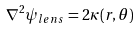Convert formula to latex. <formula><loc_0><loc_0><loc_500><loc_500>\nabla ^ { 2 } \psi _ { l e n s } = 2 \kappa ( r , \theta )</formula> 